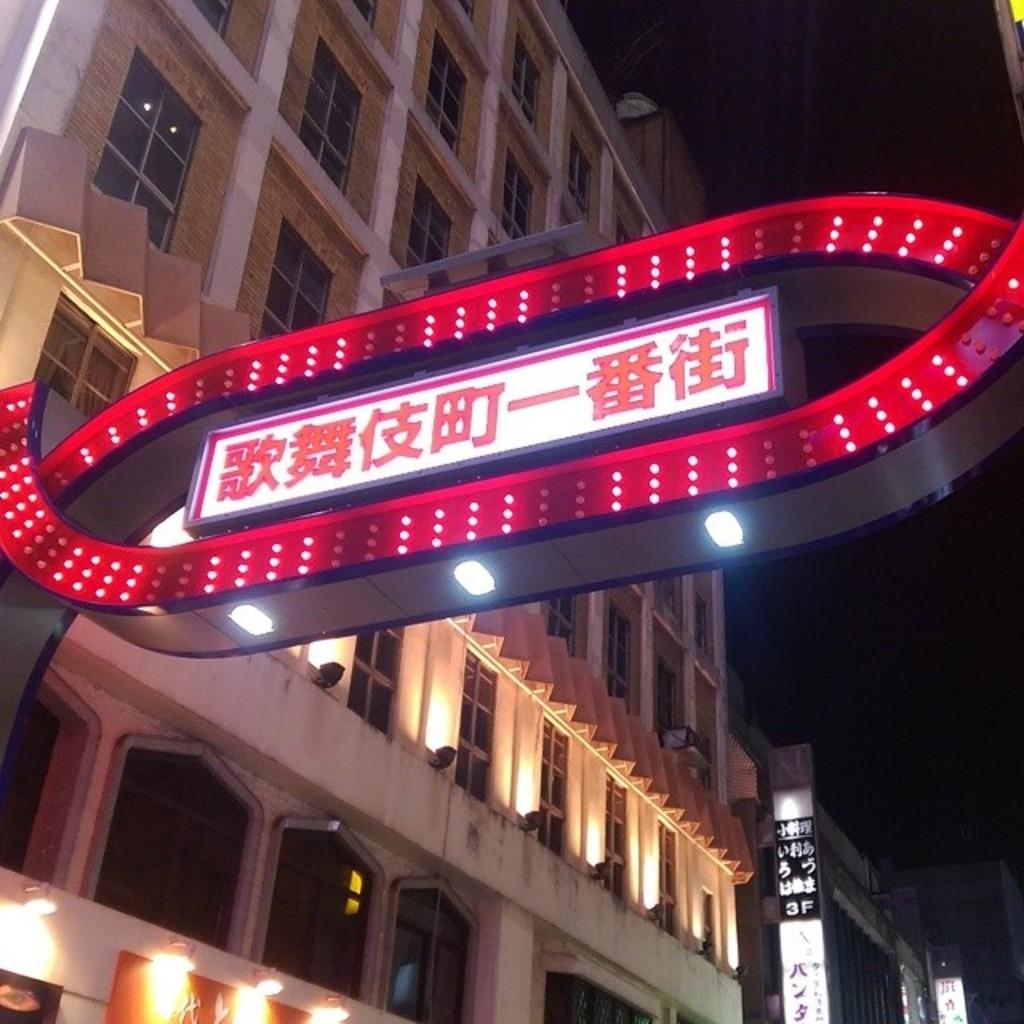What type of structures are depicted in the image? There are light boards of buildings in the image. What can be seen in the background of the image? The sky is visible in the background of the image. What type of veil is draped over the buildings in the image? There is no veil present in the image; the buildings are depicted using light boards. 